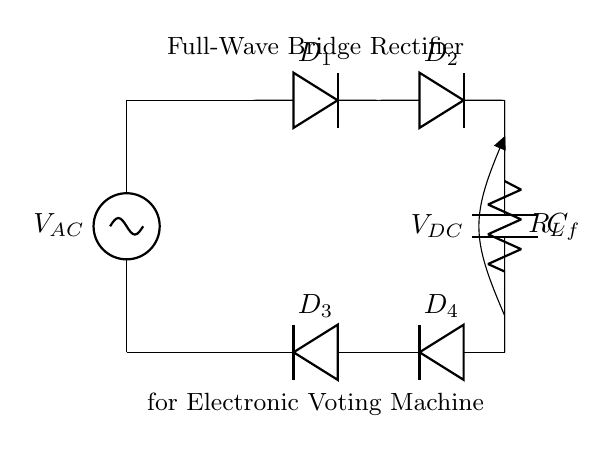what type of rectifier is shown in the diagram? The diagram depicts a full-wave bridge rectifier. This is determined by the arrangement of four diodes configured in a bridge layout allowing current to flow in both halves of the input AC waveform.
Answer: full-wave bridge rectifier how many diodes are present in the circuit? The circuit contains four diodes, as indicated by the presence of D1, D2, D3, and D4 in the diagram.
Answer: four what is the role of the capacitor in this circuit? The capacitor (C_f) in the circuit acts as a filter to smooth out the rectified output voltage by charging and discharging, thereby reducing ripple in the DC output.
Answer: smoothing what happens to the output voltage when the AC input voltage increases? When the AC input voltage increases, the output DC voltage (V_DC) also increases proportionally, as the rectifier passes a greater voltage through to the load.
Answer: increases which components are responsible for converting AC to DC? The four diodes (D1, D2, D3, D4) form the bridge rectifier, which is responsible for converting the alternating current (AC) input to direct current (DC) output.
Answer: diodes what is the load resistor labeled as in the circuit? The load resistor is labeled as R_L in the circuit diagram. This label identifies the component that consumes the DC power supplied by the rectifier.
Answer: R_L 